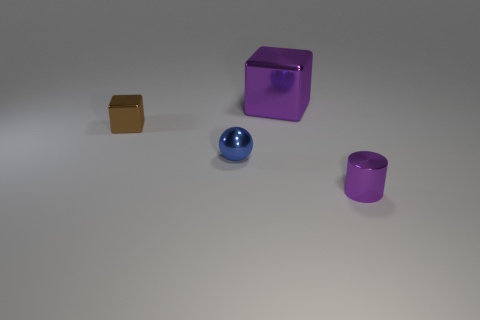Add 4 tiny brown objects. How many objects exist? 8 Subtract all cylinders. How many objects are left? 3 Subtract 0 cyan cylinders. How many objects are left? 4 Subtract all balls. Subtract all brown rubber objects. How many objects are left? 3 Add 2 spheres. How many spheres are left? 3 Add 4 balls. How many balls exist? 5 